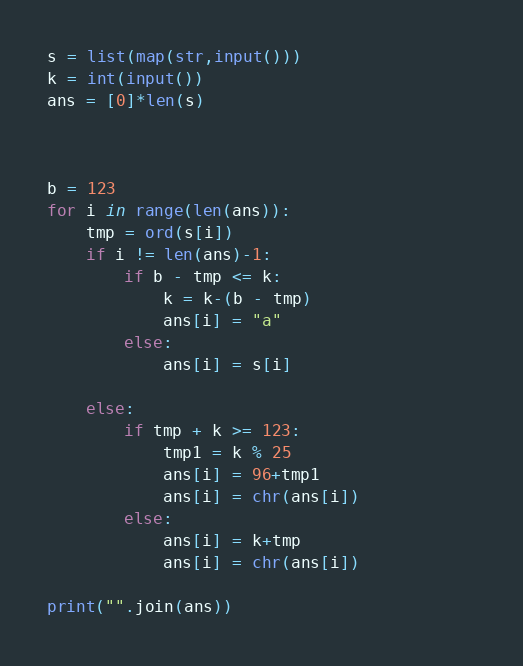Convert code to text. <code><loc_0><loc_0><loc_500><loc_500><_Python_>s = list(map(str,input()))
k = int(input())
ans = [0]*len(s)



b = 123
for i in range(len(ans)):
    tmp = ord(s[i])
    if i != len(ans)-1:
        if b - tmp <= k:
            k = k-(b - tmp)
            ans[i] = "a"
        else:
            ans[i] = s[i]
    
    else:
        if tmp + k >= 123:
            tmp1 = k % 25
            ans[i] = 96+tmp1
            ans[i] = chr(ans[i])            
        else:
            ans[i] = k+tmp
            ans[i] = chr(ans[i])
            
print("".join(ans))</code> 